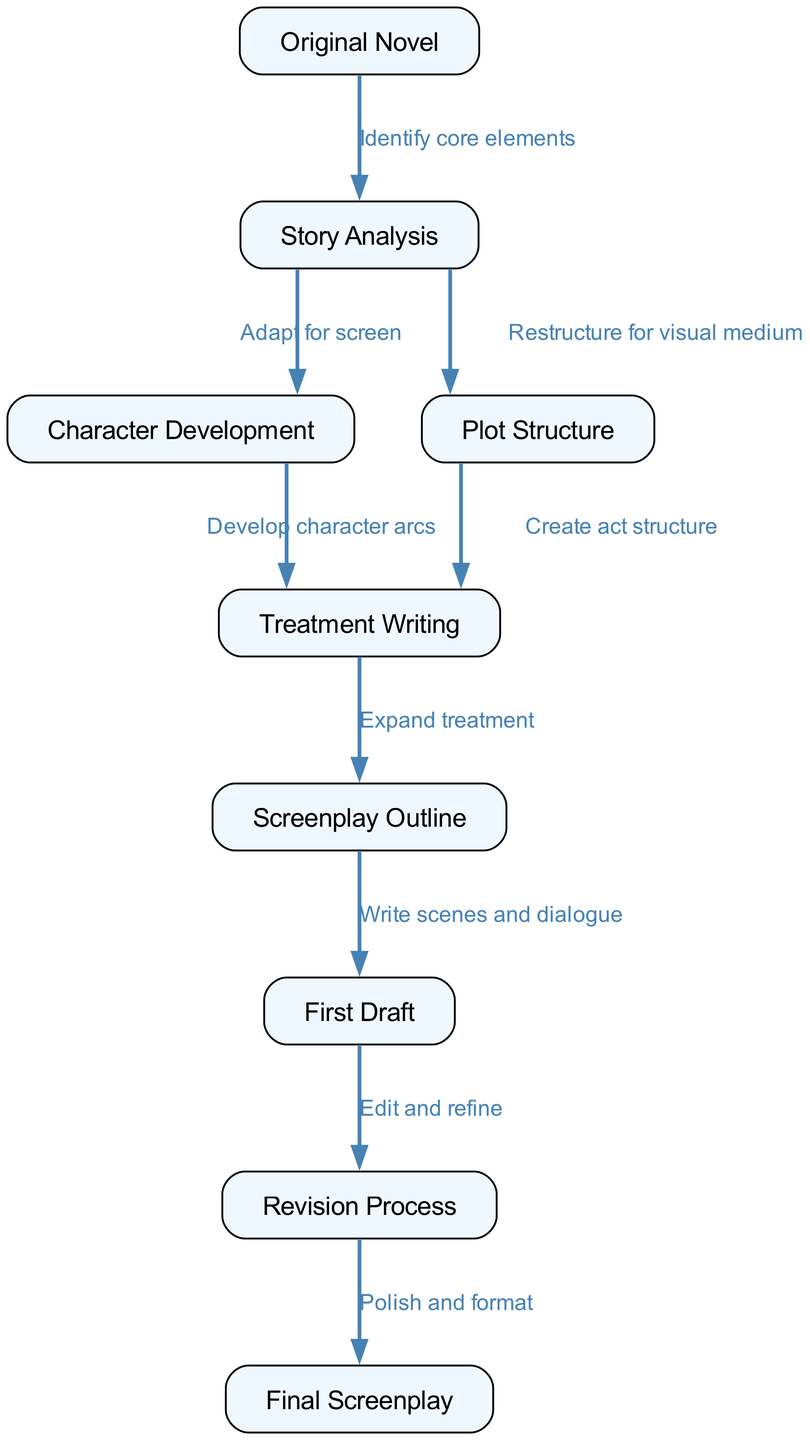What is the first node in the diagram? The first node in the flowchart is labeled "Original Novel," indicating where the adaptation process begins.
Answer: Original Novel How many edges are there in total? By counting the relationships between the nodes in the diagram, we find there are nine edges connecting the different stages of the adaptation process.
Answer: 9 What transformation occurs from "Story Analysis" to "Character Development"? The edge connecting these two nodes states "Adapt for screen," indicating that character elements will be adapted specifically for the film medium during this transition.
Answer: Adapt for screen Which node comes after "Screenplay Outline"? Following the "Screenplay Outline" node, the next step indicated is "First Draft," where writing of scenes and dialogue occurs based on the outline.
Answer: First Draft What type of writing follows "Treatment Writing"? After "Treatment Writing," the process progresses to "Screenplay Outline," which focuses on outlining and structuring the screenplay.
Answer: Screenplay Outline What key decision point is involved in the transition from "Plot Structure" to "Treatment Writing"? The transition involves "Create act structure," determining how the plot is organized into acts, which is essential for writing the treatment.
Answer: Create act structure What does the "Revision Process" lead to? The "Revision Process" leads to the "Final Screenplay," which involves polishing and formatting the screenplay prior to its completion.
Answer: Final Screenplay How many nodes directly lead from "Story Analysis"? "Story Analysis" has two edges leading to two different nodes, namely "Character Development" and "Plot Structure," indicating parallel pathways in the adaptation process.
Answer: 2 What is the primary function of the "First Draft" node? The "First Draft" node primarily represents the writing of scenes and dialogue, marking a crucial step where the story is realized on the page.
Answer: Write scenes and dialogue 